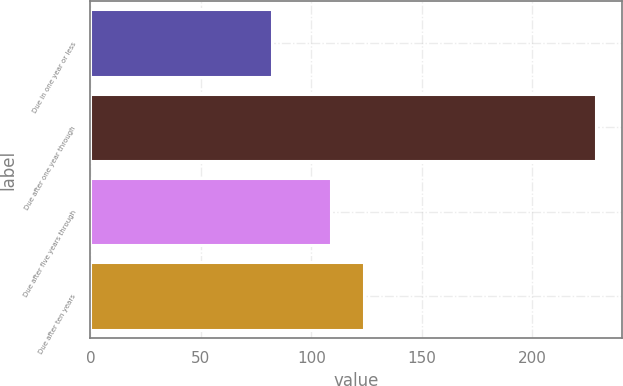Convert chart to OTSL. <chart><loc_0><loc_0><loc_500><loc_500><bar_chart><fcel>Due in one year or less<fcel>Due after one year through<fcel>Due after five years through<fcel>Due after ten years<nl><fcel>82<fcel>229<fcel>109<fcel>123.7<nl></chart> 